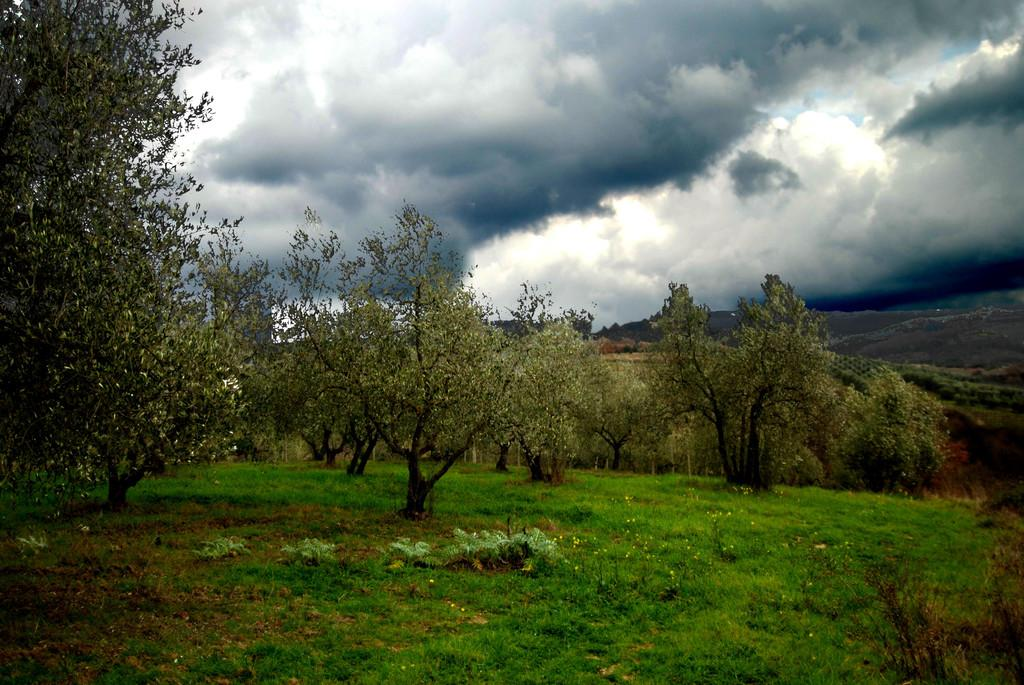What type of vegetation is at the bottom of the image? There is grass at the bottom of the image. What other types of plants can be seen in the image? There are plants with flowers in the image. What else is present on the ground in the image? There are trees on the ground in the image. What can be seen in the background of the image? There is grass and clouds visible in the background of the image. What color is the rock suit worn by the person in the image? There is no person wearing a rock suit in the image; it features plants, trees, and grass. 